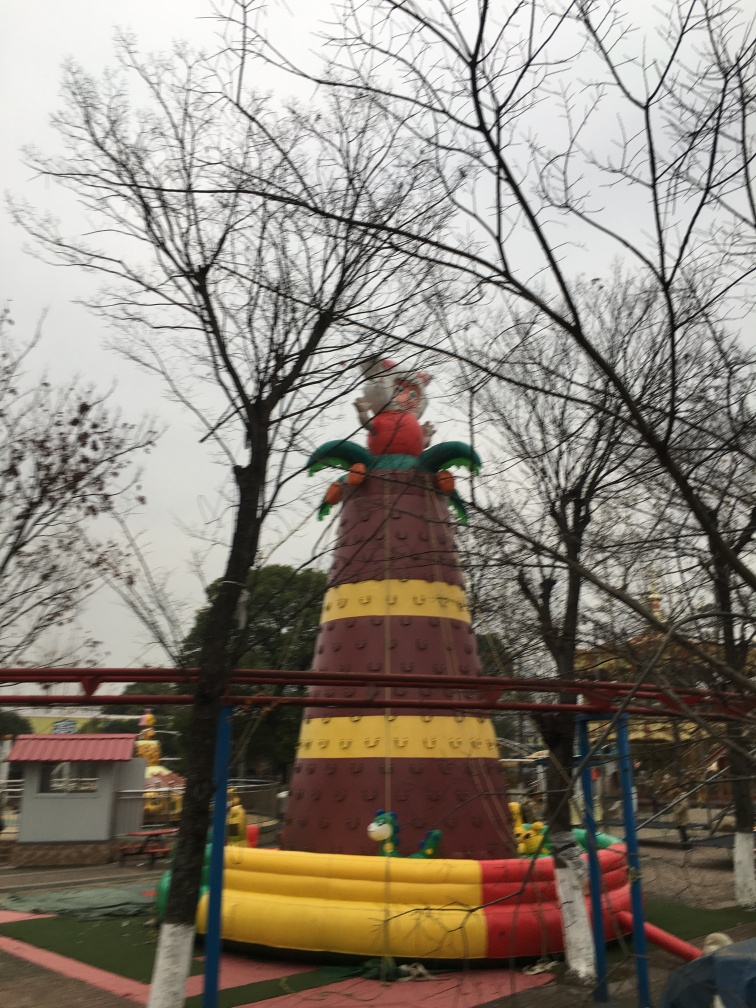Does the image have sufficient lighting? The lighting in the image is quite dim which may be due to overcast weather, resulting in a lack of sufficient natural light to illuminate the scene brightly. 